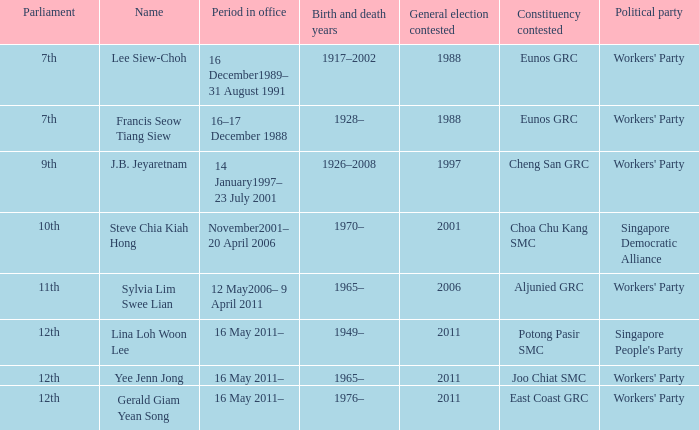What parliament's name is lina loh woon lee? 12th. Could you parse the entire table as a dict? {'header': ['Parliament', 'Name', 'Period in office', 'Birth and death years', 'General election contested', 'Constituency contested', 'Political party'], 'rows': [['7th', 'Lee Siew-Choh', '16 December1989– 31 August 1991', '1917–2002', '1988', 'Eunos GRC', "Workers' Party"], ['7th', 'Francis Seow Tiang Siew', '16–17 December 1988', '1928–', '1988', 'Eunos GRC', "Workers' Party"], ['9th', 'J.B. Jeyaretnam', '14 January1997– 23 July 2001', '1926–2008', '1997', 'Cheng San GRC', "Workers' Party"], ['10th', 'Steve Chia Kiah Hong', 'November2001– 20 April 2006', '1970–', '2001', 'Choa Chu Kang SMC', 'Singapore Democratic Alliance'], ['11th', 'Sylvia Lim Swee Lian', '12 May2006– 9 April 2011', '1965–', '2006', 'Aljunied GRC', "Workers' Party"], ['12th', 'Lina Loh Woon Lee', '16 May 2011–', '1949–', '2011', 'Potong Pasir SMC', "Singapore People's Party"], ['12th', 'Yee Jenn Jong', '16 May 2011–', '1965–', '2011', 'Joo Chiat SMC', "Workers' Party"], ['12th', 'Gerald Giam Yean Song', '16 May 2011–', '1976–', '2011', 'East Coast GRC', "Workers' Party"]]} 